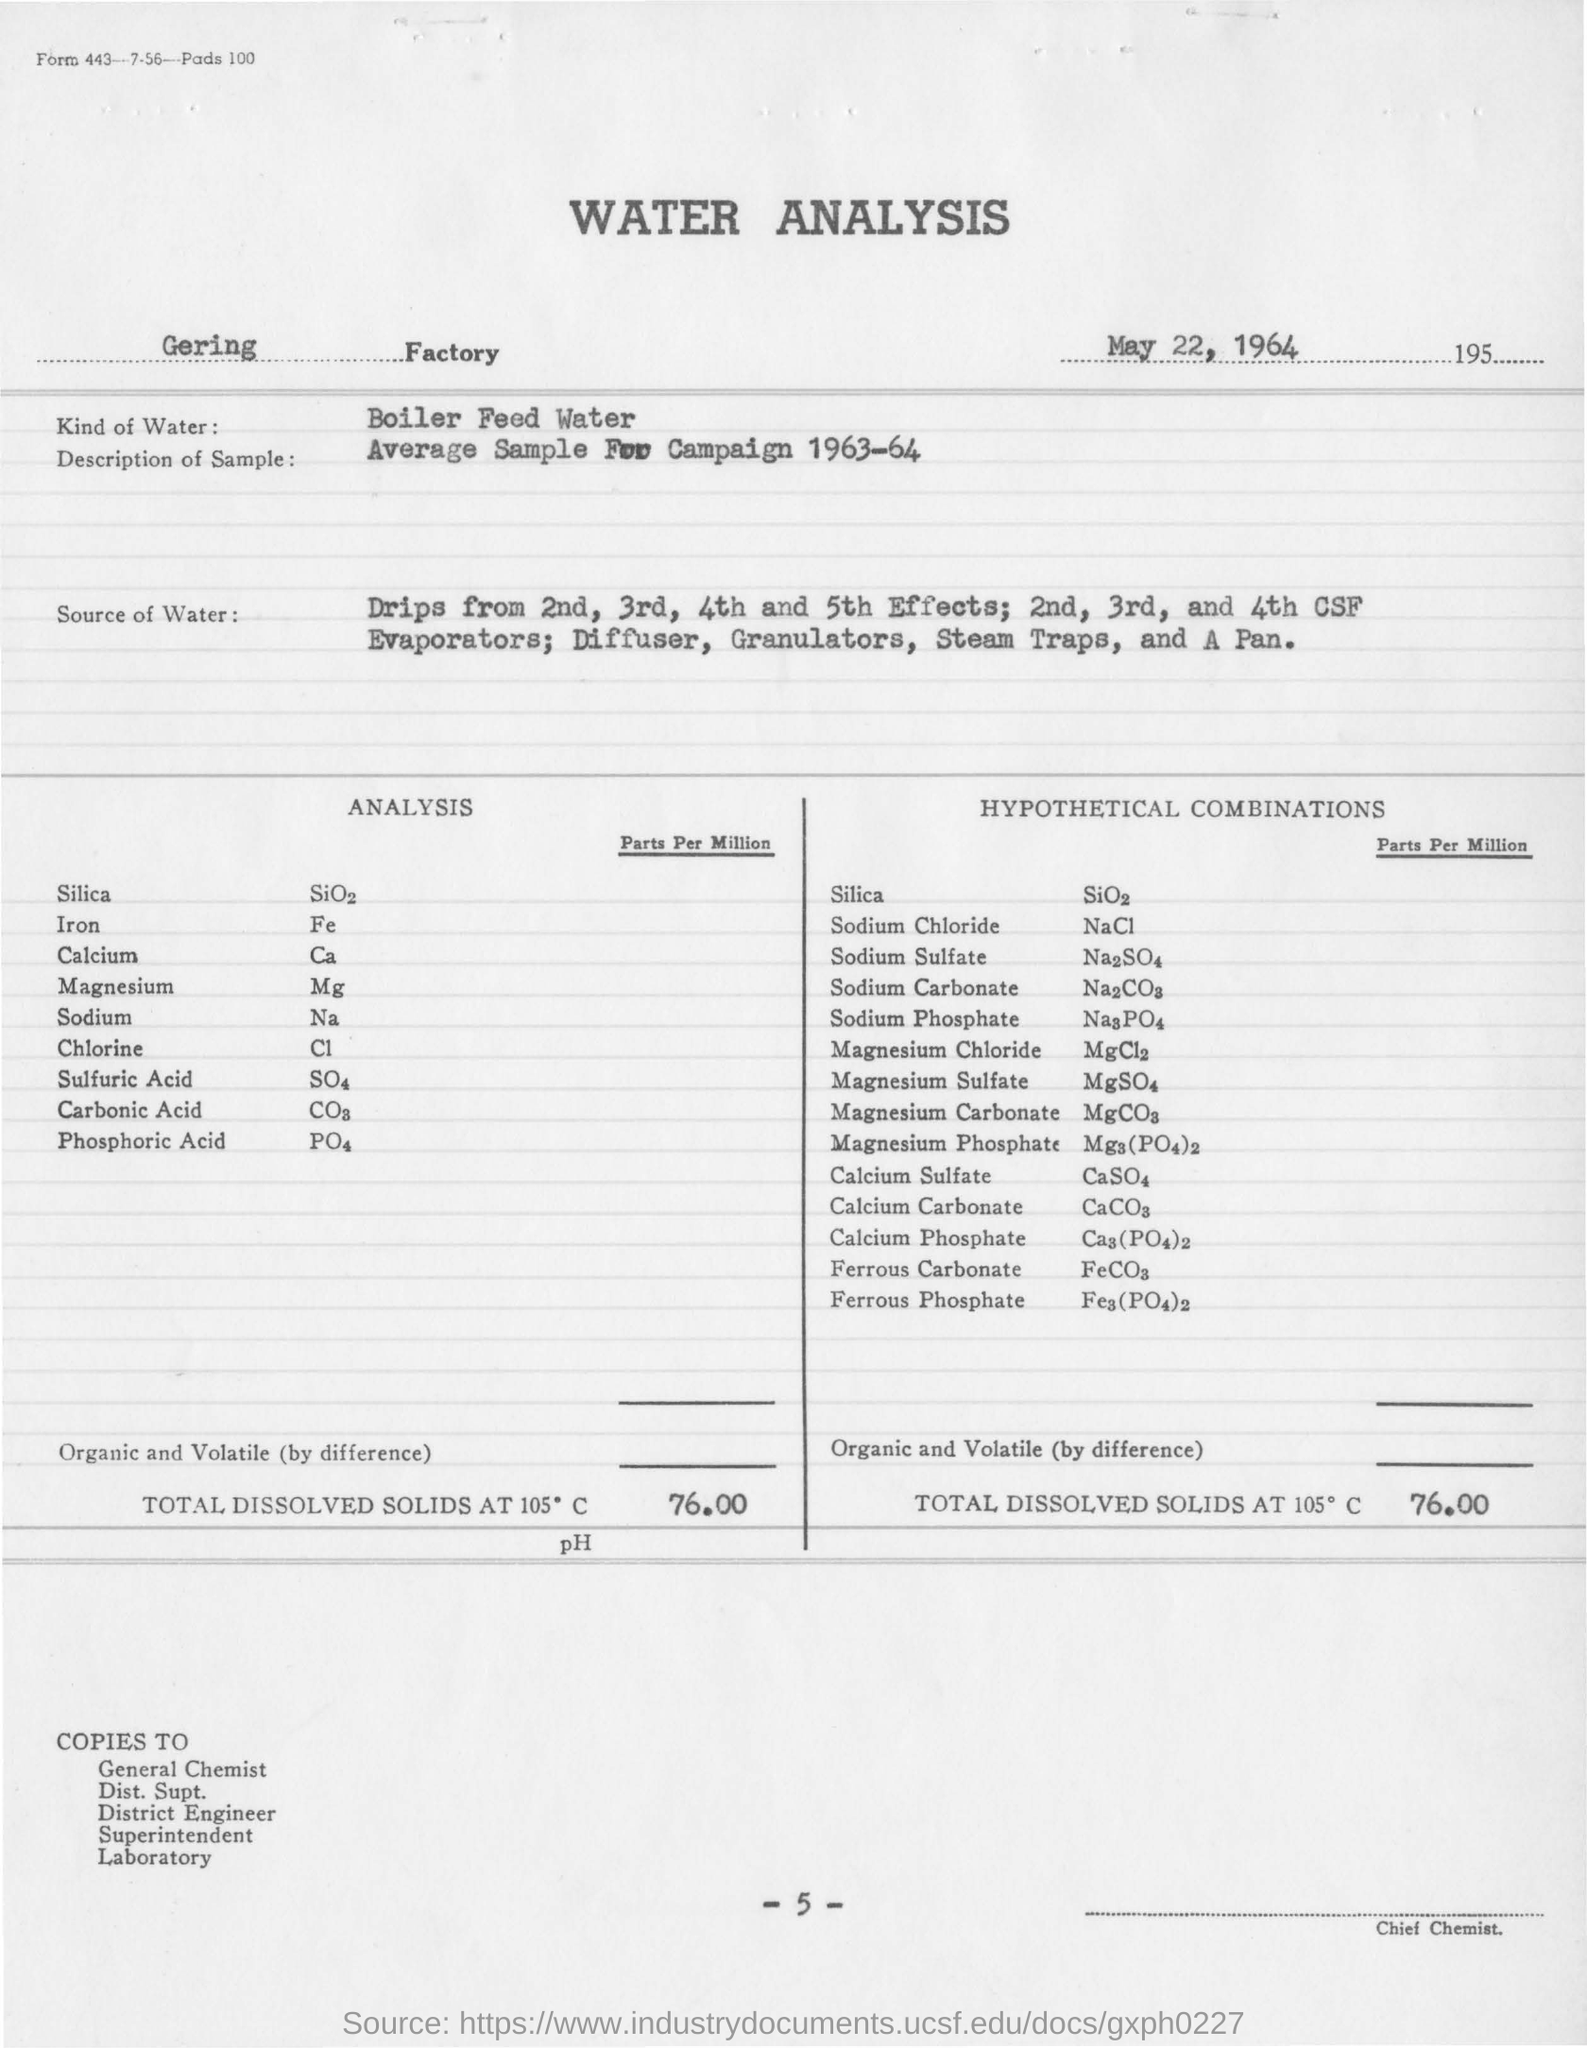What is the significance of measuring total dissolved solids in water analysis? Measuring total dissolved solids (TDS) is critical in water analysis because it indicates the combined content of all inorganic and organic substances contained in a liquid. In boiler systems, high levels of TDS can lead to issues like scaling, corrosion, or foaming, which can compromise the efficiency and longevity of the boiler. The recorded TDS value of 76.00 parts per million on this report suggests that the water is being maintained within an acceptable range for use in industrial boilers. 